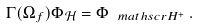<formula> <loc_0><loc_0><loc_500><loc_500>\Gamma ( \Omega _ { f } ) \Phi _ { \mathcal { H } } = \Phi _ { \ m a t h s c r H ^ { + } } \, .</formula> 